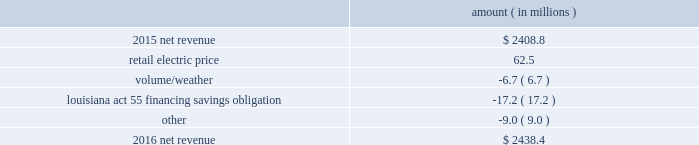The retail electric price variance is primarily due to an increase in formula rate plan revenues , implemented with the first billing cycle of march 2016 , to collect the estimated first-year revenue requirement related to the purchase of power blocks 3 and 4 of the union power station in march 2016 and a provision recorded in 2016 related to the settlement of the waterford 3 replacement steam generator prudence review proceeding .
See note 2 to the financial statements for further discussion of the formula rate plan revenues and the waterford 3 replacement steam generator prudence review proceeding .
The louisiana act 55 financing savings obligation variance results from a regulatory charge recorded in 2016 for tax savings to be shared with customers per an agreement approved by the lpsc .
The tax savings resulted from the 2010-2011 irs audit settlement on the treatment of the louisiana act 55 financing of storm costs for hurricane gustav and hurricane ike .
See note 3 to the financial statements for additional discussion of the settlement and benefit sharing .
The volume/weather variance is primarily due to the effect of less favorable weather on residential and commercial sales and decreased usage during the unbilled sales period .
The decrease was partially offset by an increase of 1237 gwh , or 4% ( 4 % ) , in industrial usage primarily due to an increase in demand from existing customers and expansion projects in the chemicals industry .
2016 compared to 2015 net revenue consists of operating revenues net of : 1 ) fuel , fuel-related expenses , and gas purchased for resale , 2 ) purchased power expenses , and 3 ) other regulatory charges .
Following is an analysis of the change in net revenue comparing 2016 to 2015 .
Amount ( in millions ) .
The retail electric price variance is primarily due to an increase in formula rate plan revenues , implemented with the first billing cycle of march 2016 , to collect the estimated first-year revenue requirement related to the purchase of power blocks 3 and 4 of the union power station .
See note 2 to the financial statements for further discussion .
The volume/weather variance is primarily due to the effect of less favorable weather on residential sales , partially offset by an increase in industrial usage and an increase in volume during the unbilled period .
The increase in industrial usage is primarily due to increased demand from new customers and expansion projects , primarily in the chemicals industry .
The louisiana act 55 financing savings obligation variance results from a regulatory charge for tax savings to be shared with customers per an agreement approved by the lpsc .
The tax savings resulted from the 2010-2011 irs audit settlement on the treatment of the louisiana act 55 financing of storm costs for hurricane gustav and hurricane ike .
See note 3 to the financial statements for additional discussion of the settlement and benefit sharing .
Included in other is a provision of $ 23 million recorded in 2016 related to the settlement of the waterford 3 replacement steam generator prudence review proceeding , offset by a provision of $ 32 million recorded in 2015 related to the uncertainty at that time associated with the resolution of the waterford 3 replacement steam generator prudence entergy louisiana , llc and subsidiaries management 2019s financial discussion and analysis .
What was the percentage increase in net revenue in 2016? 
Computations: ((2438.4 - 2408.8) / 2408.8)
Answer: 0.01229. 